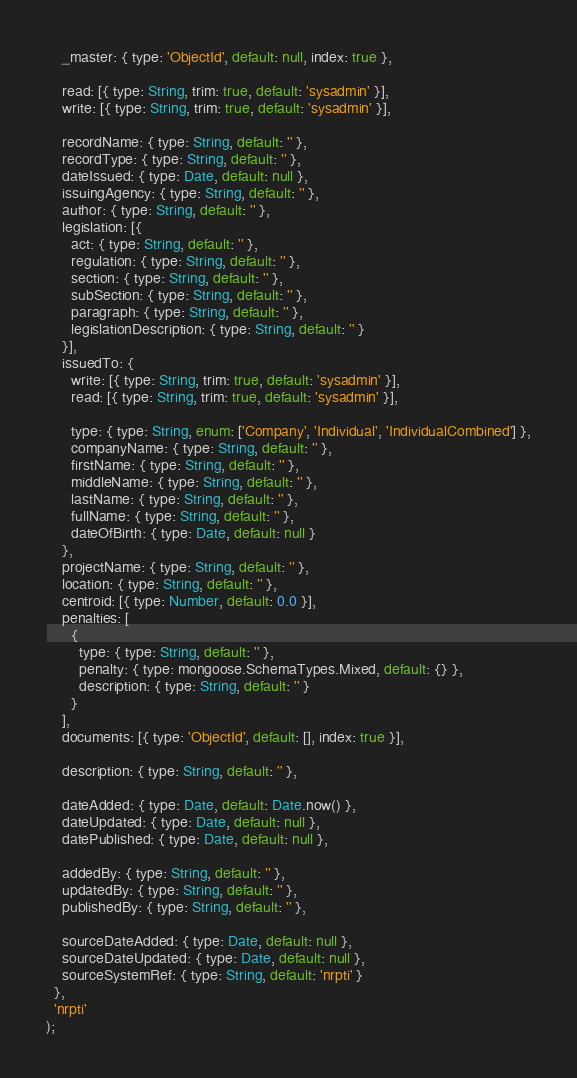Convert code to text. <code><loc_0><loc_0><loc_500><loc_500><_JavaScript_>    _master: { type: 'ObjectId', default: null, index: true },

    read: [{ type: String, trim: true, default: 'sysadmin' }],
    write: [{ type: String, trim: true, default: 'sysadmin' }],

    recordName: { type: String, default: '' },
    recordType: { type: String, default: '' },
    dateIssued: { type: Date, default: null },
    issuingAgency: { type: String, default: '' },
    author: { type: String, default: '' },
    legislation: [{
      act: { type: String, default: '' },
      regulation: { type: String, default: '' },
      section: { type: String, default: '' },
      subSection: { type: String, default: '' },
      paragraph: { type: String, default: '' },
      legislationDescription: { type: String, default: '' }
    }],
    issuedTo: {
      write: [{ type: String, trim: true, default: 'sysadmin' }],
      read: [{ type: String, trim: true, default: 'sysadmin' }],

      type: { type: String, enum: ['Company', 'Individual', 'IndividualCombined'] },
      companyName: { type: String, default: '' },
      firstName: { type: String, default: '' },
      middleName: { type: String, default: '' },
      lastName: { type: String, default: '' },
      fullName: { type: String, default: '' },
      dateOfBirth: { type: Date, default: null }
    },
    projectName: { type: String, default: '' },
    location: { type: String, default: '' },
    centroid: [{ type: Number, default: 0.0 }],
    penalties: [
      {
        type: { type: String, default: '' },
        penalty: { type: mongoose.SchemaTypes.Mixed, default: {} },
        description: { type: String, default: '' }
      }
    ],
    documents: [{ type: 'ObjectId', default: [], index: true }],

    description: { type: String, default: '' },

    dateAdded: { type: Date, default: Date.now() },
    dateUpdated: { type: Date, default: null },
    datePublished: { type: Date, default: null },

    addedBy: { type: String, default: '' },
    updatedBy: { type: String, default: '' },
    publishedBy: { type: String, default: '' },

    sourceDateAdded: { type: Date, default: null },
    sourceDateUpdated: { type: Date, default: null },
    sourceSystemRef: { type: String, default: 'nrpti' }
  },
  'nrpti'
);
</code> 